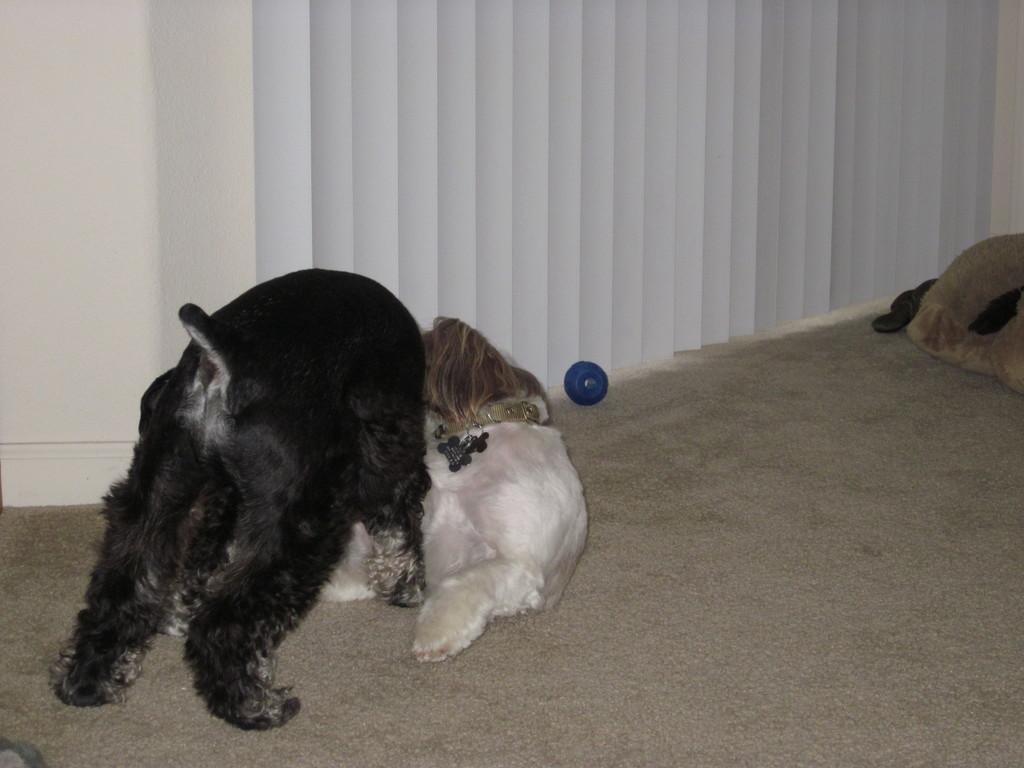Describe this image in one or two sentences. In this image, there are animals on the floor and one of them is wearing a belt and we can see a blue color object. In the background, there is a wall and we can see curtains. 